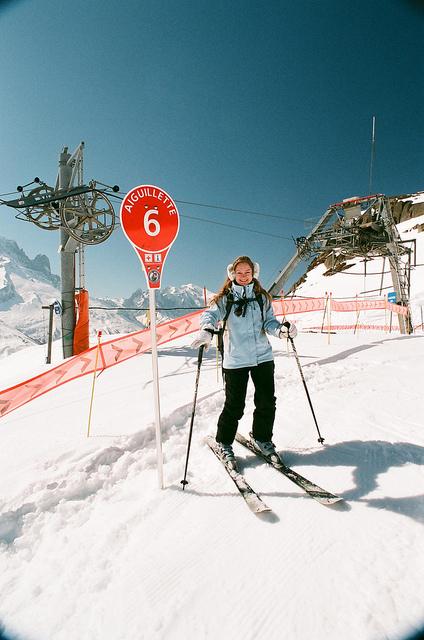Does she look sad?
Short answer required. No. What is the woman holding in her hands?
Write a very short answer. Ski poles. What number is on the sign?
Concise answer only. 6. 